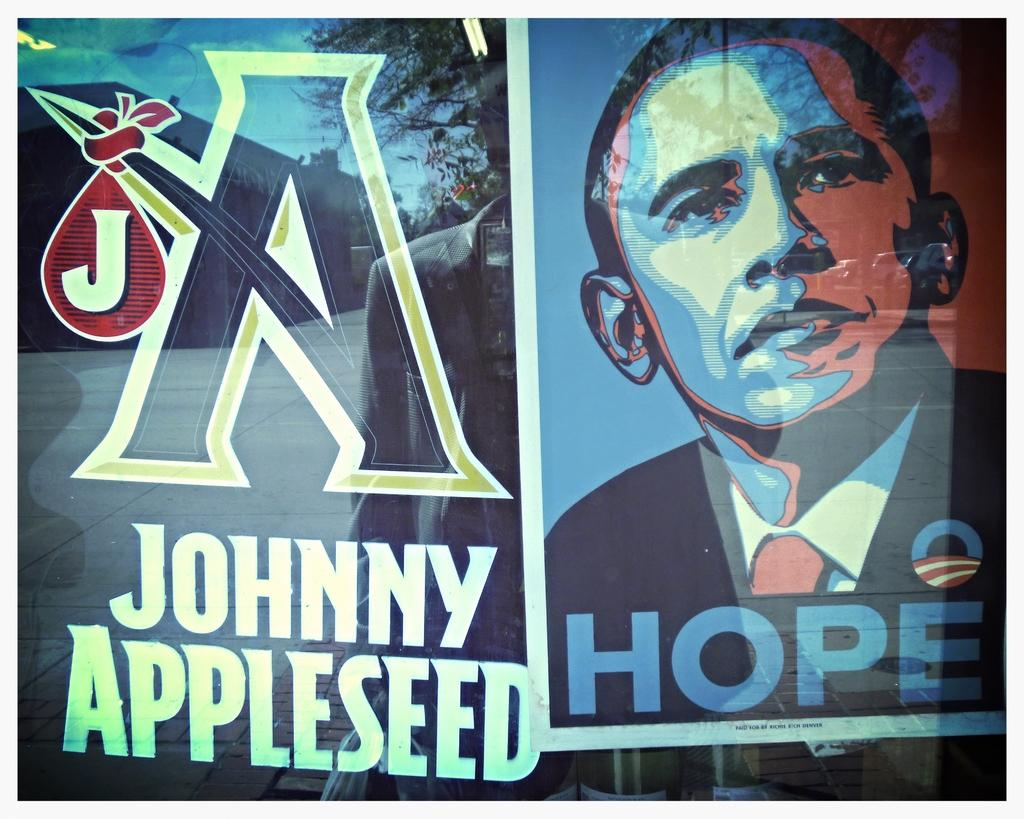<image>
Render a clear and concise summary of the photo. A sign for Johnny appleseed that has a picture of Obama that says Hope. 